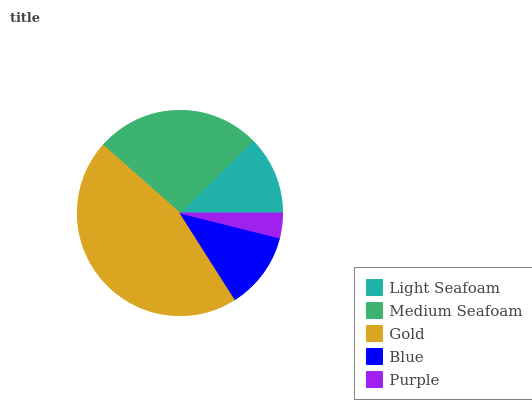Is Purple the minimum?
Answer yes or no. Yes. Is Gold the maximum?
Answer yes or no. Yes. Is Medium Seafoam the minimum?
Answer yes or no. No. Is Medium Seafoam the maximum?
Answer yes or no. No. Is Medium Seafoam greater than Light Seafoam?
Answer yes or no. Yes. Is Light Seafoam less than Medium Seafoam?
Answer yes or no. Yes. Is Light Seafoam greater than Medium Seafoam?
Answer yes or no. No. Is Medium Seafoam less than Light Seafoam?
Answer yes or no. No. Is Light Seafoam the high median?
Answer yes or no. Yes. Is Light Seafoam the low median?
Answer yes or no. Yes. Is Purple the high median?
Answer yes or no. No. Is Blue the low median?
Answer yes or no. No. 